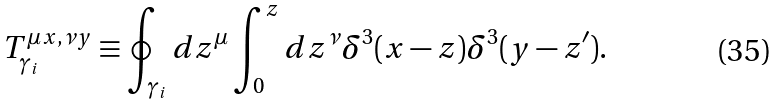Convert formula to latex. <formula><loc_0><loc_0><loc_500><loc_500>T _ { \gamma _ { i } } ^ { \mu x , \nu y } \equiv \oint _ { \gamma _ { i } } d z ^ { \mu } \int _ { 0 } ^ { z } d z ^ { \nu } \delta ^ { 3 } ( x - z ) \delta ^ { 3 } ( y - z ^ { \prime } ) .</formula> 